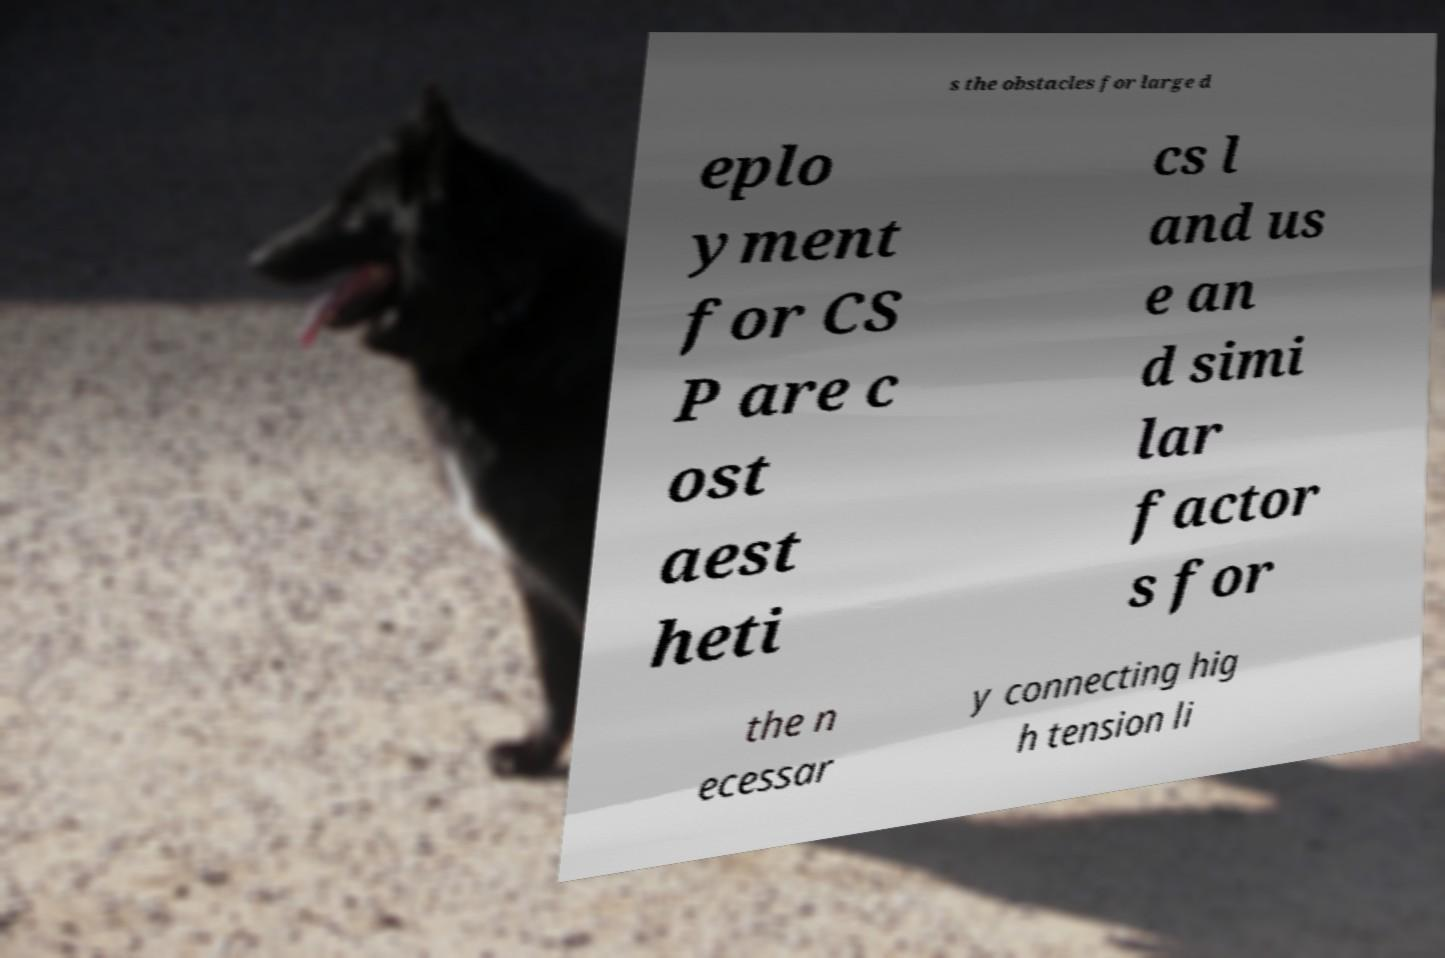Please read and relay the text visible in this image. What does it say? s the obstacles for large d eplo yment for CS P are c ost aest heti cs l and us e an d simi lar factor s for the n ecessar y connecting hig h tension li 